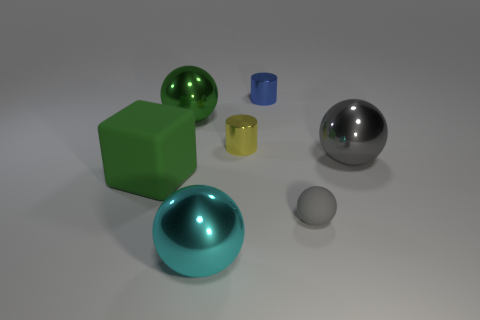Are there any other rubber things that have the same color as the small matte object?
Make the answer very short. No. Are the cyan thing and the blue cylinder made of the same material?
Provide a short and direct response. Yes. How many purple metal things are the same shape as the large cyan metallic thing?
Provide a short and direct response. 0. What shape is the small blue thing that is the same material as the cyan ball?
Ensure brevity in your answer.  Cylinder. There is a large sphere in front of the large matte cube to the left of the gray matte ball; what is its color?
Provide a succinct answer. Cyan. What material is the gray thing behind the big green object to the left of the big green shiny ball?
Your answer should be compact. Metal. There is a large green object that is the same shape as the big gray metallic object; what is its material?
Keep it short and to the point. Metal. There is a shiny sphere that is right of the tiny metallic thing behind the yellow shiny cylinder; is there a small yellow cylinder behind it?
Provide a succinct answer. Yes. How many other things are the same color as the big rubber thing?
Your response must be concise. 1. How many gray objects are in front of the green rubber object and behind the green cube?
Provide a short and direct response. 0. 